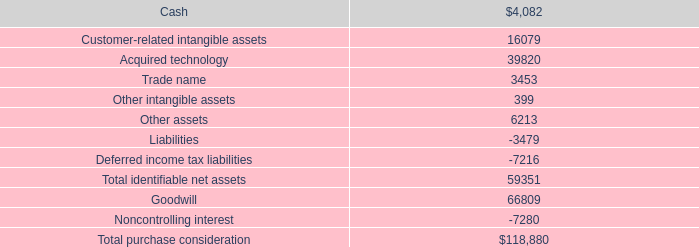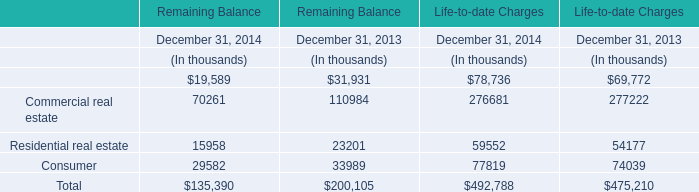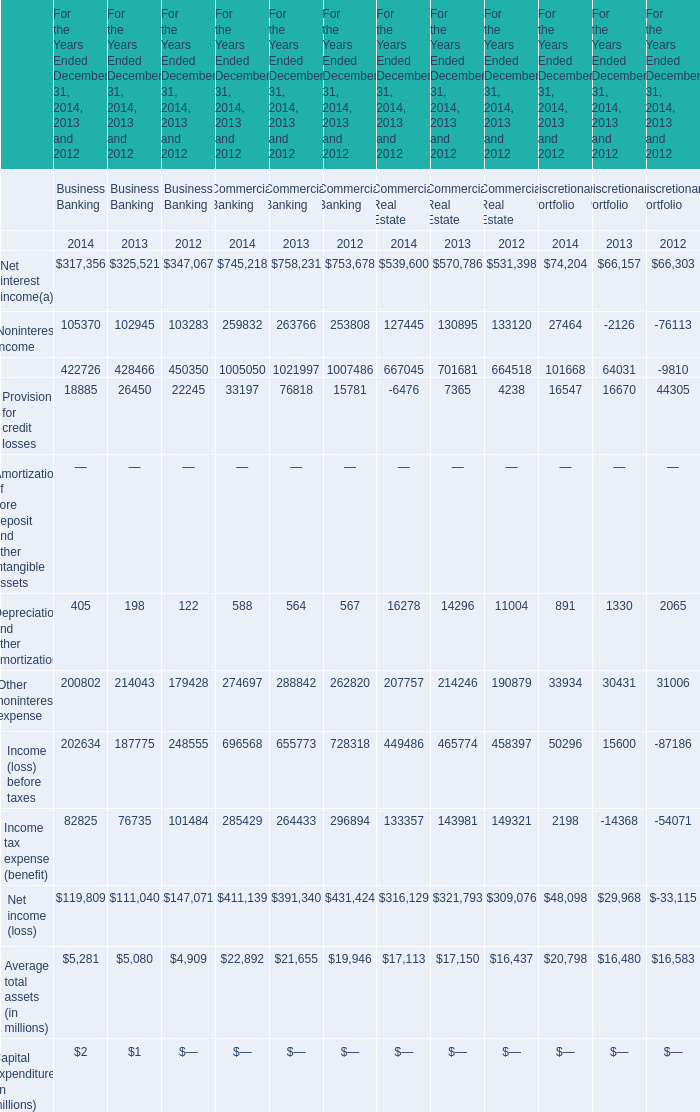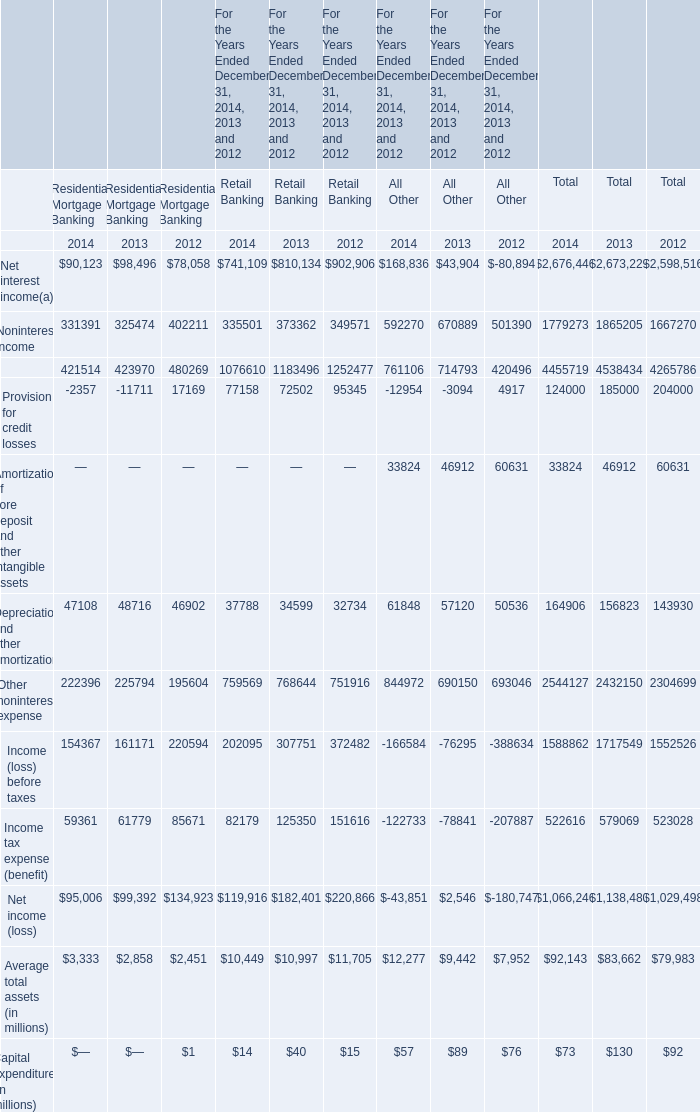What's the sum of all All Other that are positive in 2014? (in million) 
Computations: ((((((168836 + 592270) + 33824) + 61848) + 844972) + 12277) + 57)
Answer: 1714084.0. 